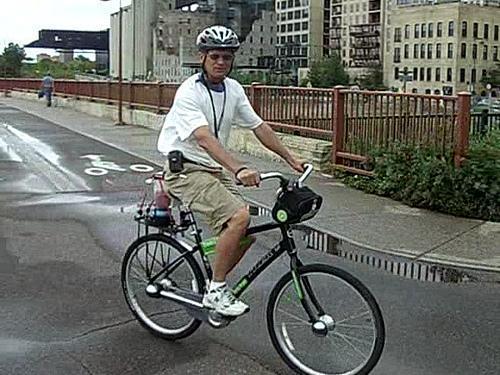How many people are in the picture?
Give a very brief answer. 2. 